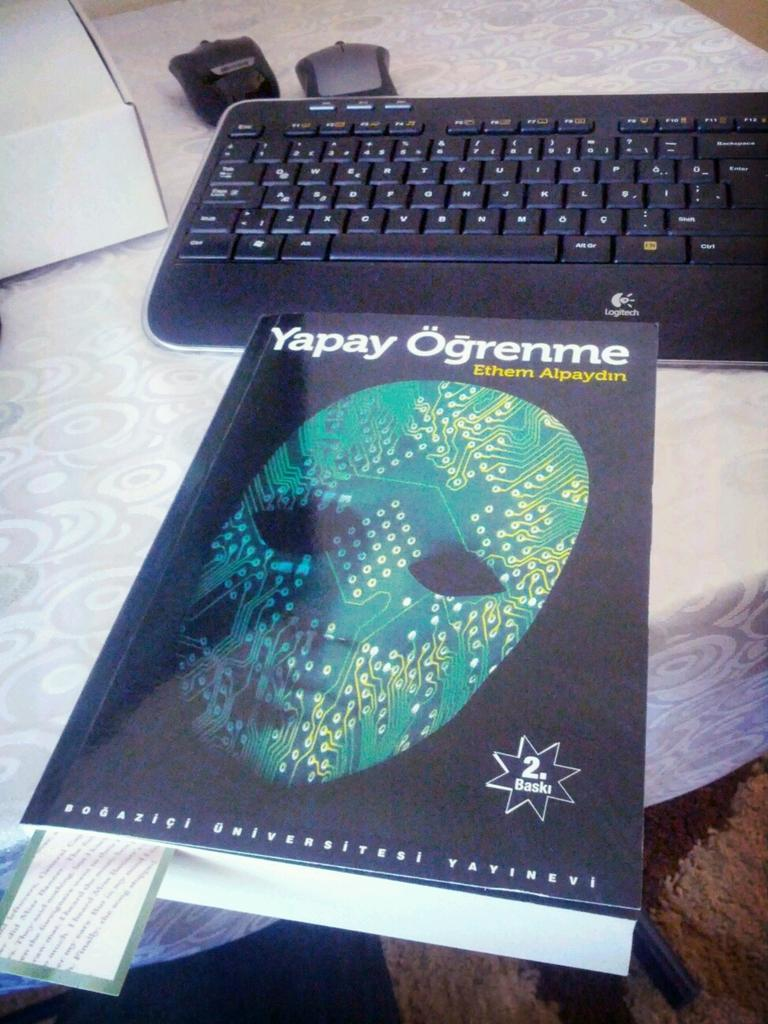What is the main piece of furniture in the image? There is a table in the image. What is placed on the table? There is a keyboard, at least two mouses, and a book on the table. Can you describe the book on the table? The book on the table has a mask picture on it. What is the distance between the two mouses on the table? The provided facts do not give information about the distance between the mouses, so it cannot be determined from the image. 